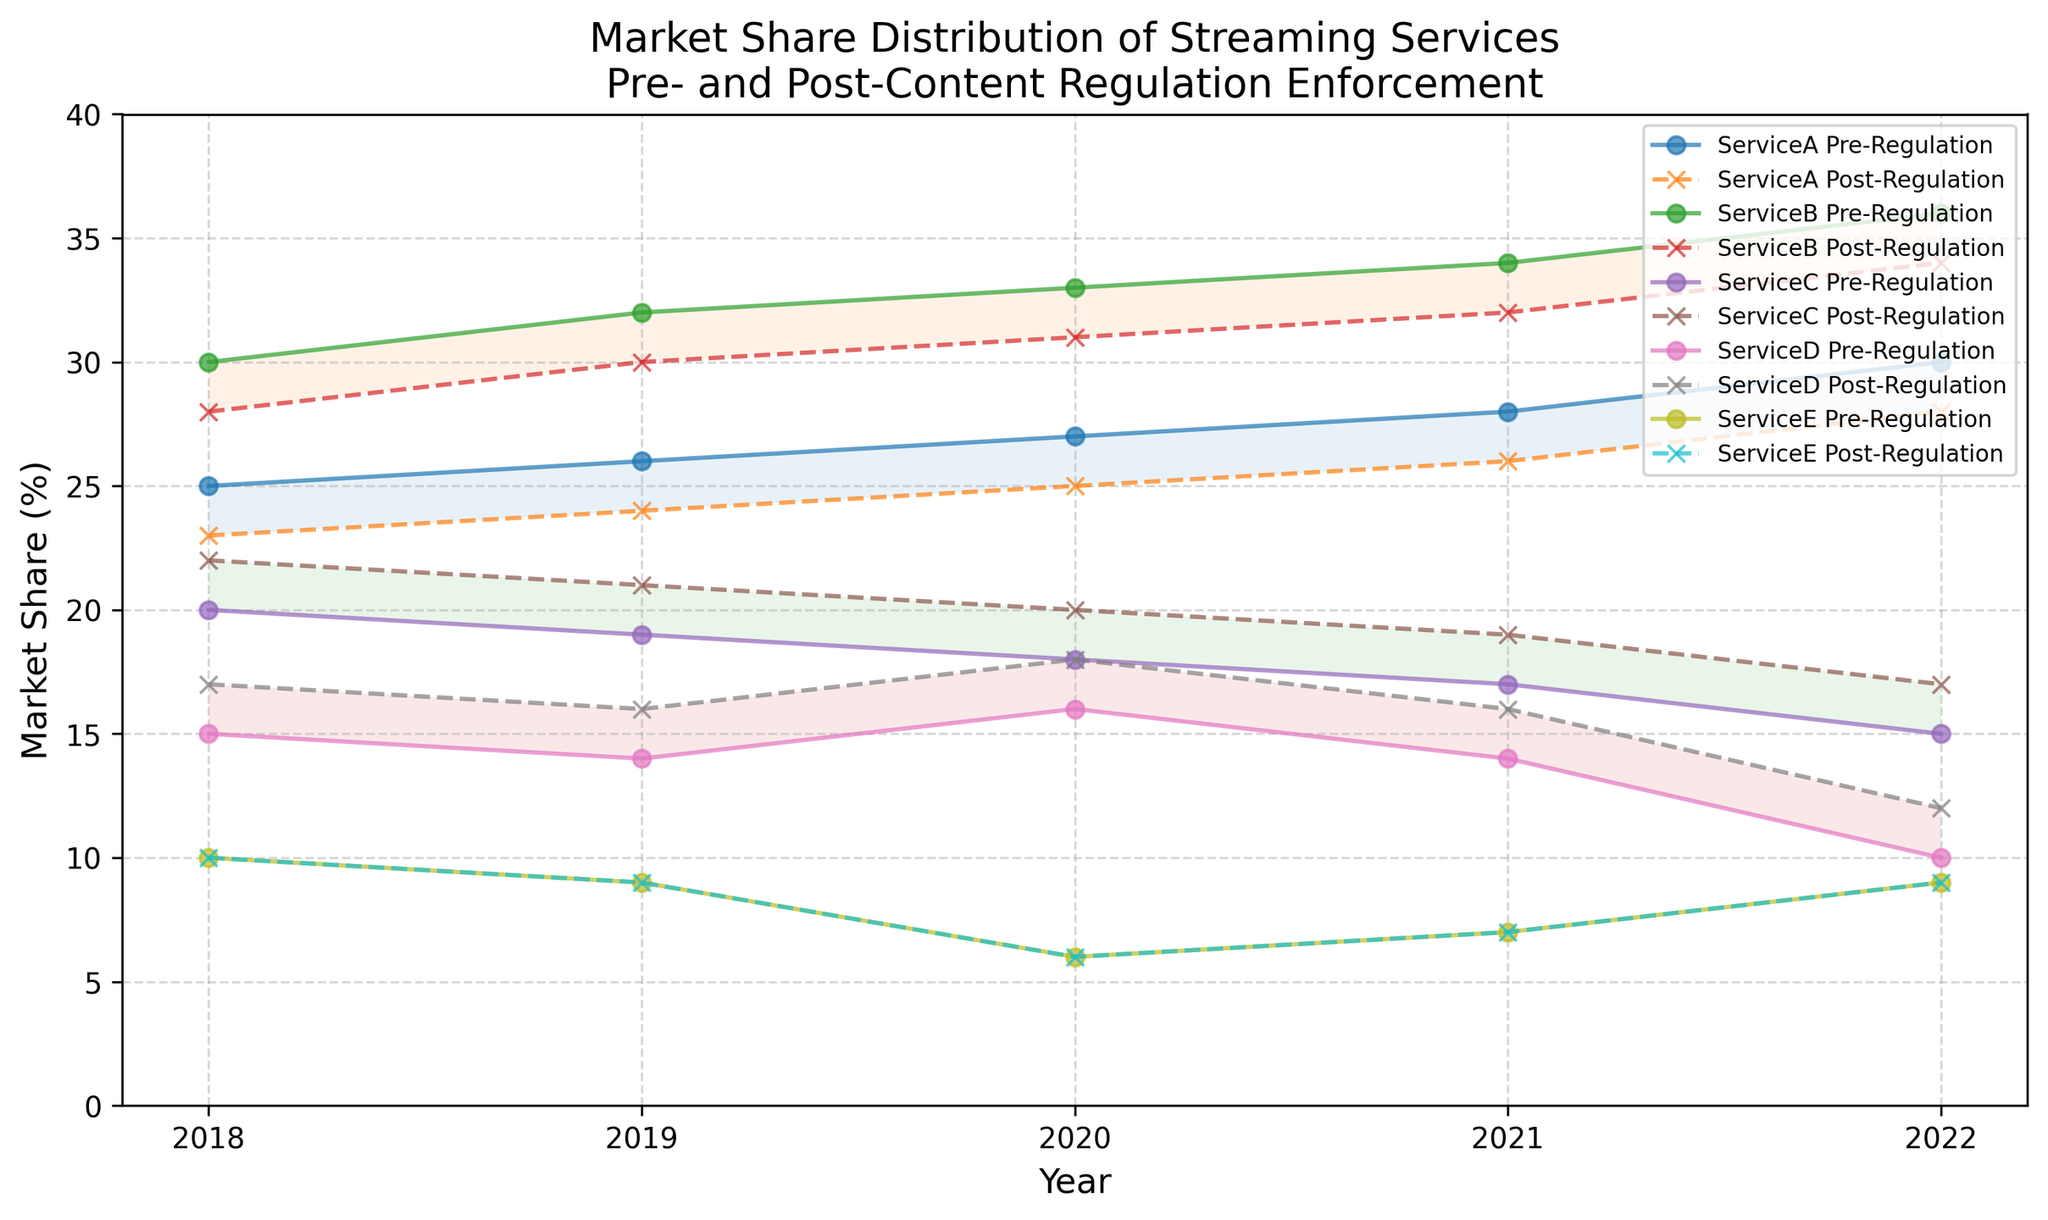What is the market share difference for Service A between Pre-Regulation and Post-Regulation in 2022? To find the difference, subtract the Post-Regulation market share from the Pre-Regulation market share for Service A in 2022. This is 30% - 28% = 2%.
Answer: 2% Which service had the highest market share in 2020 Post-Regulation? Look at the Post-Regulation market shares for all services in 2020. Service B has the highest market share at 31%.
Answer: Service B How did the market share for Service D change from 2019 Pre-Regulation to 2021 Post-Regulation? Calculate the change by comparing the 2019 Pre-Regulation market share (14%) to the 2021 Post-Regulation market share (16%). The increase is 16% - 14% = 2%.
Answer: Increased by 2% What is the average market share for Service C Post-Regulation over the years 2018 to 2022? Add up the Post-Regulation market shares for Service C from 2018 to 2022: 22% + 21% + 20% + 19% + 17% = 99%. Divide this by 5 to get the average: 99% / 5 = 19.8%.
Answer: 19.8% Between which two consecutive years did Service A's Pre-Regulation market share increase the most? Calculate the year-to-year changes: (1) 2018 to 2019: 26% - 25% = 1%, (2) 2019 to 2020: 27% - 26% = 1%, (3) 2020 to 2021: 28% - 27% = 1%, (4) 2021 to 2022: 30% - 28% = 2%. The biggest increase was from 2021 to 2022 by 2%.
Answer: 2021 to 2022 Which service showed no change in market share post-regulation from 2018 to 2022? Checking the Post-Regulation market shares for each service from 2018 to 2022, Service E remained constant at 10% (2018-2020) and 9% (2021-2022).
Answer: Service E Did any service experience a decrease in market share from 2019 to 2020 Pre-Regulation? If so, which one? Look at the Pre-Regulation shares: Service C dropped from 19% (2019) to 18% (2020).
Answer: Service C How much did Service B's market share increase from 2018 to 2022 Post-Regulation? Calculate the increase in market share from 2018 (28%) to 2022 (34%) for Service B. The increase is 34% - 28% = 6%.
Answer: 6% Comparing Pre-Regulation and Post-Regulation market share in 2021, which service had the smallest difference? Calculate the differences for each service in 2021. Service A: 28%-26%=2%, Service B: 34%-32%=2%, Service C: 17%-19%=2%, Service D: 14%-16%=2%, Service E: 7%-7%=0%. Service E had the smallest difference (0%).
Answer: Service E Which year did Service D see its highest Pre-Regulation market share and what was it? Check Service D's Pre-Regulation market shares over the years. The highest was in 2020 with 16%.
Answer: 2020 and 16% 